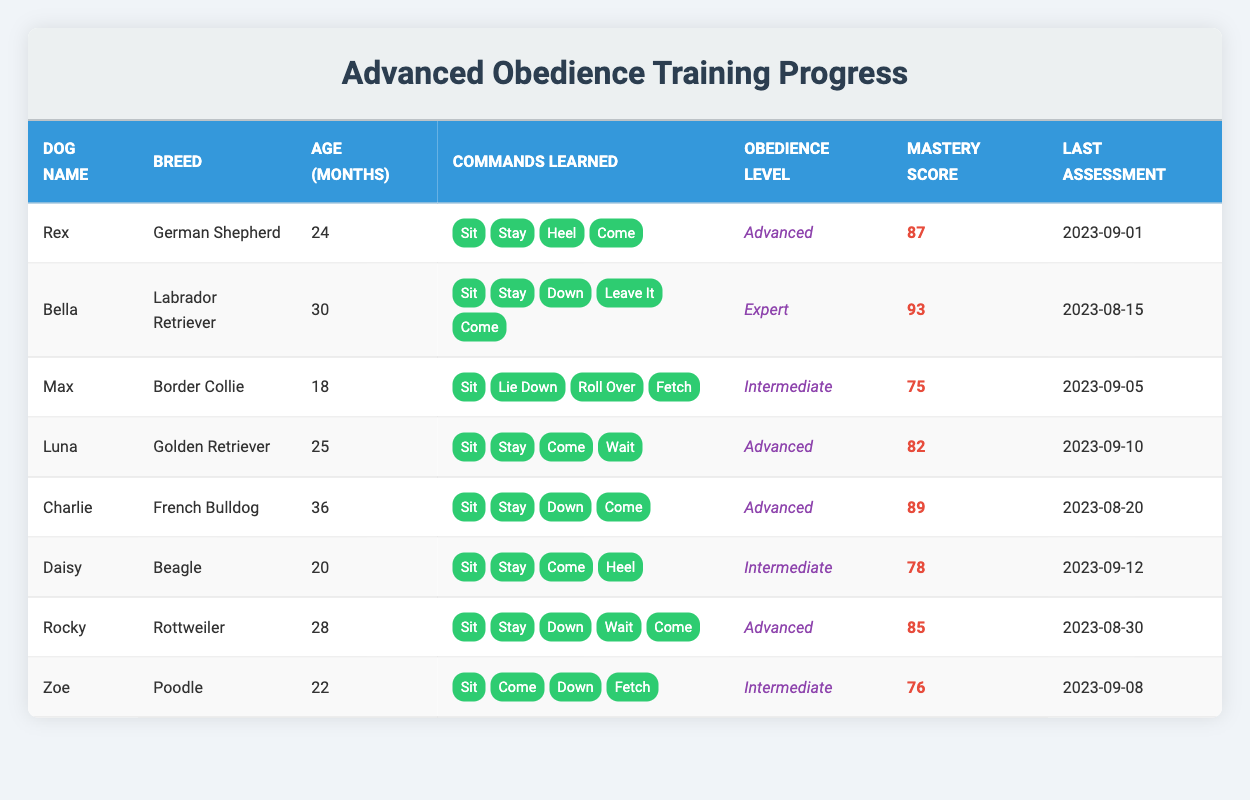What is the name of the dog with the highest mastery score? By reviewing the mastery scores listed in the table, I see that Bella has a mastery score of 93, which is the highest among all the dogs.
Answer: Bella How many commands has Daisy learned? Looking at the commands learned column for Daisy, I find that she has learned 4 commands: Sit, Stay, Come, and Heel.
Answer: 4 Which dog has the lowest mastery score in the intermediate level? Daisy and Zoe are the only dogs in the intermediate level. Daisy has a mastery score of 78 and Zoe has 76. Comparing these, Zoe has the lowest score.
Answer: Zoe What is the average age of the dogs in the advanced obedience level? The dogs in the advanced level are Rex (24 months), Luna (25 months), Charlie (36 months), and Rocky (28 months). Adding these ages gives 24 + 25 + 36 + 28 = 113 months; dividing by 4 dogs yields an average age of 113 / 4 = 28.25 months.
Answer: 28.25 Is Charlie a Labrador Retriever? Checking the breed listed for Charlie in the table, I find that his breed is French Bulldog, not Labrador Retriever.
Answer: No What is the difference in mastery scores between the expert and advanced levels? The expert level is represented by Bella with a mastery score of 93. In the advanced level, the mastery scores are 87 (Rex), 82 (Luna), 89 (Charlie), and 85 (Rocky). The average score for advanced is (87 + 82 + 89 + 85) / 4 = 85.75. The difference between Bella's score and the average advanced score is 93 - 85.75 = 7.25.
Answer: 7.25 Which dog has learned the command 'Leave It'? Looking through the commands learned by each dog, only Bella includes the command 'Leave It'.
Answer: Bella Is Max older than Rocky? Checking the ages of Max and Rocky, Max is 18 months and Rocky is 28 months, which means Max is younger than Rocky. Therefore, the statement is false.
Answer: No 